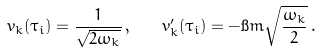<formula> <loc_0><loc_0><loc_500><loc_500>v _ { k } ( \tau _ { i } ) = \frac { 1 } { \sqrt { 2 \omega _ { k } } } \, , \quad v ^ { \prime } _ { k } ( \tau _ { i } ) = - \i m \sqrt { \frac { \omega _ { k } } { 2 } } \, .</formula> 